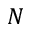Convert formula to latex. <formula><loc_0><loc_0><loc_500><loc_500>N</formula> 